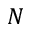Convert formula to latex. <formula><loc_0><loc_0><loc_500><loc_500>N</formula> 